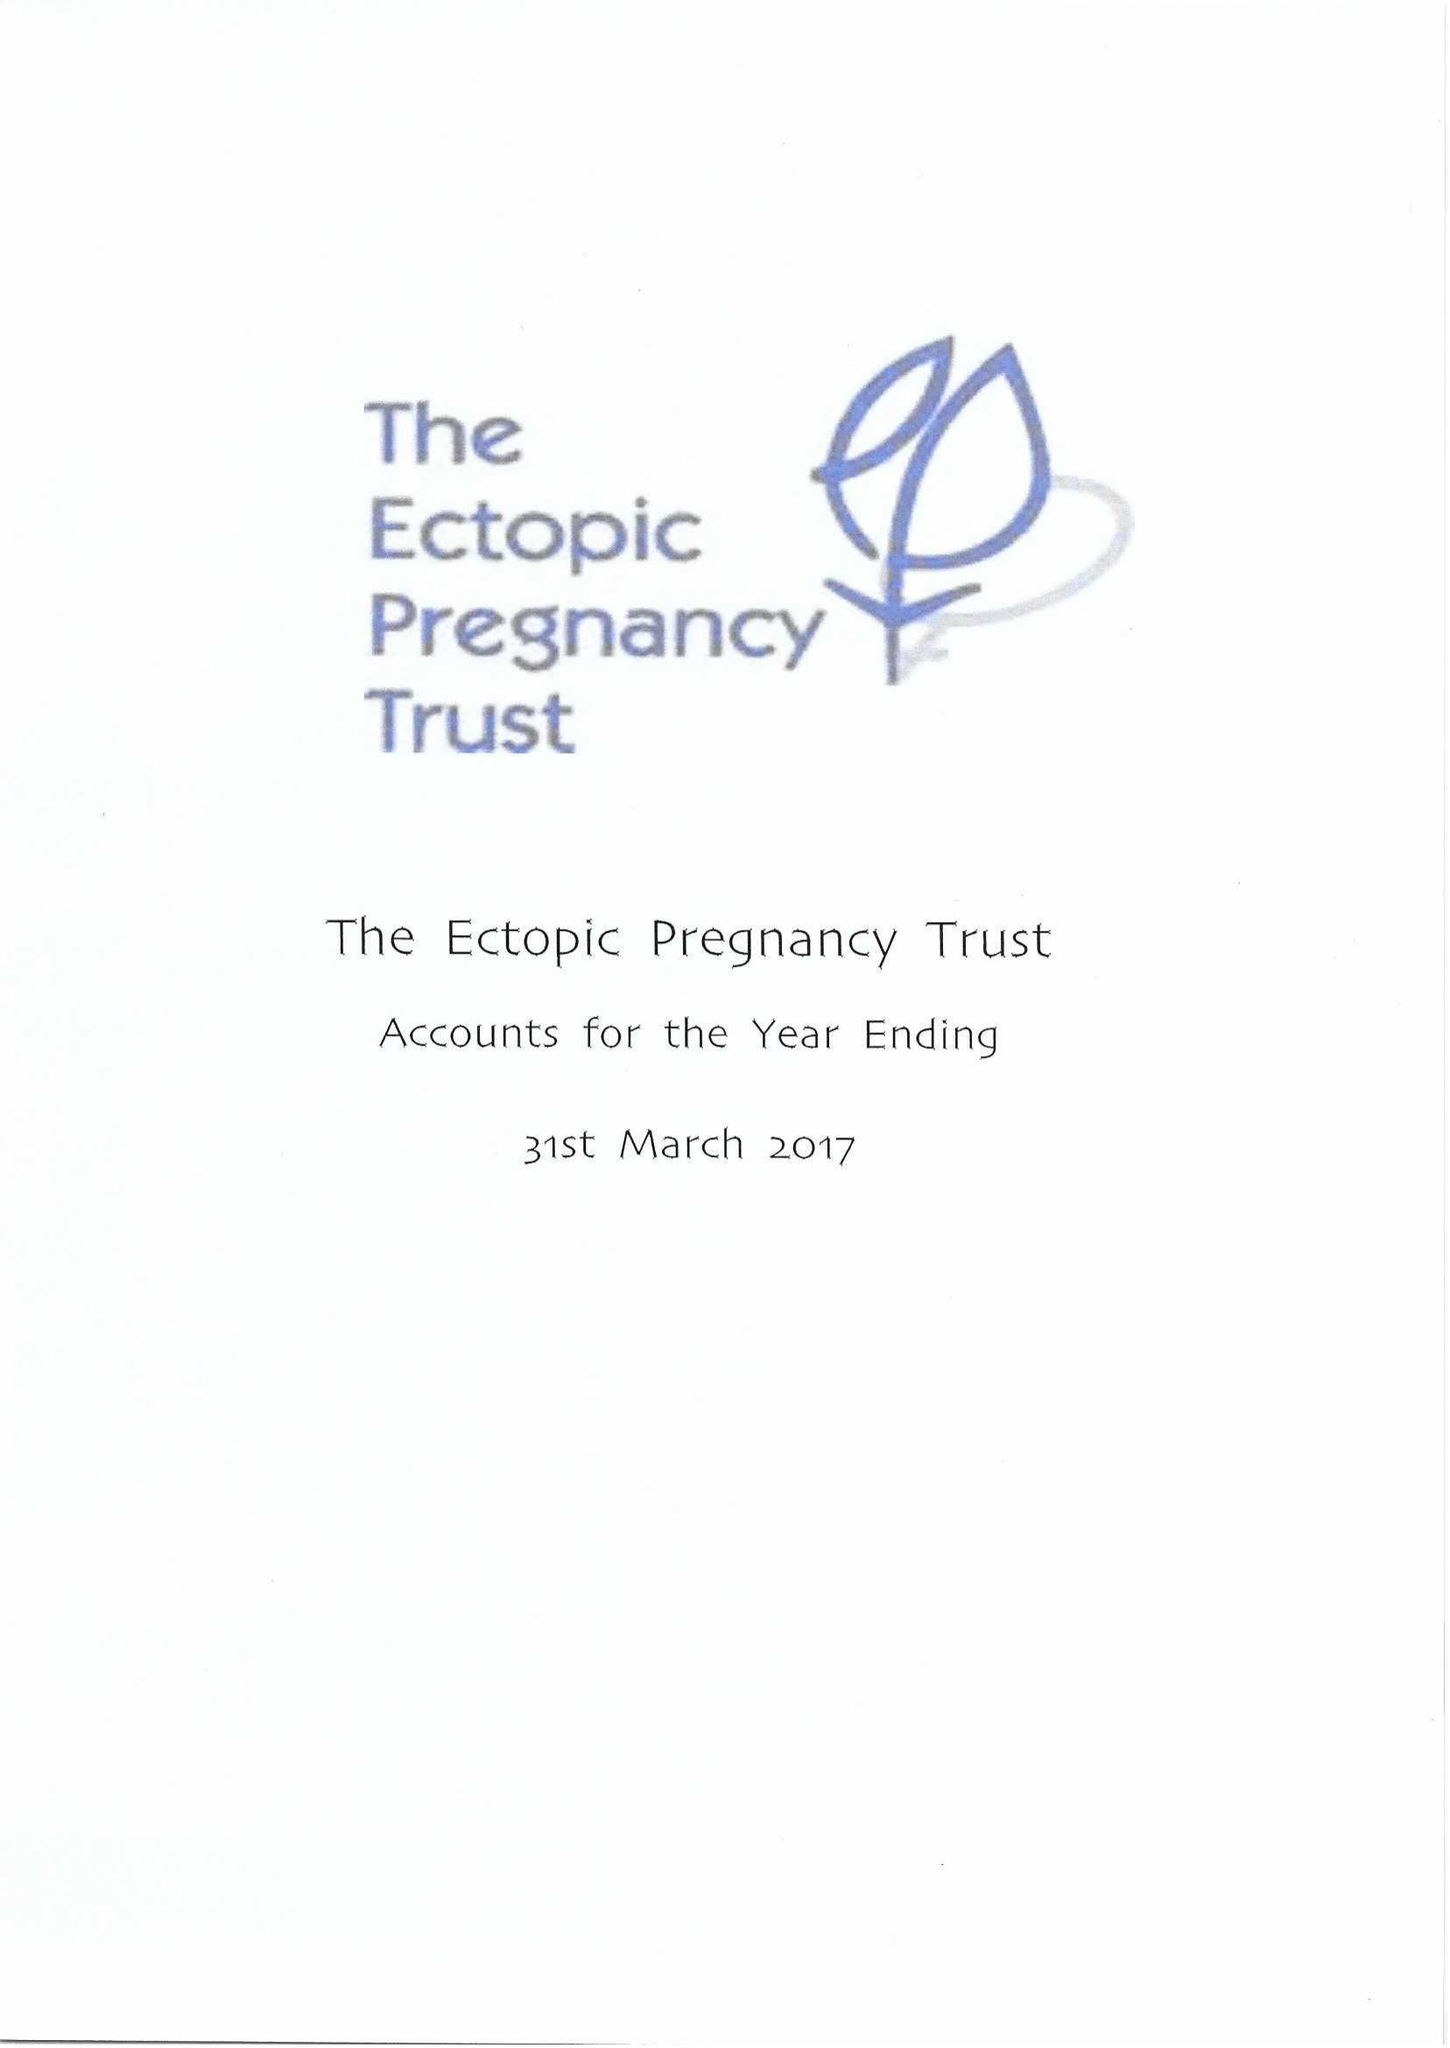What is the value for the address__street_line?
Answer the question using a single word or phrase. 483 GREEN LANES 